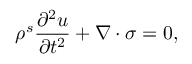Convert formula to latex. <formula><loc_0><loc_0><loc_500><loc_500>\rho ^ { s } \frac { \partial ^ { 2 } u } { \partial t ^ { 2 } } + \nabla \cdot \sigma = 0 ,</formula> 